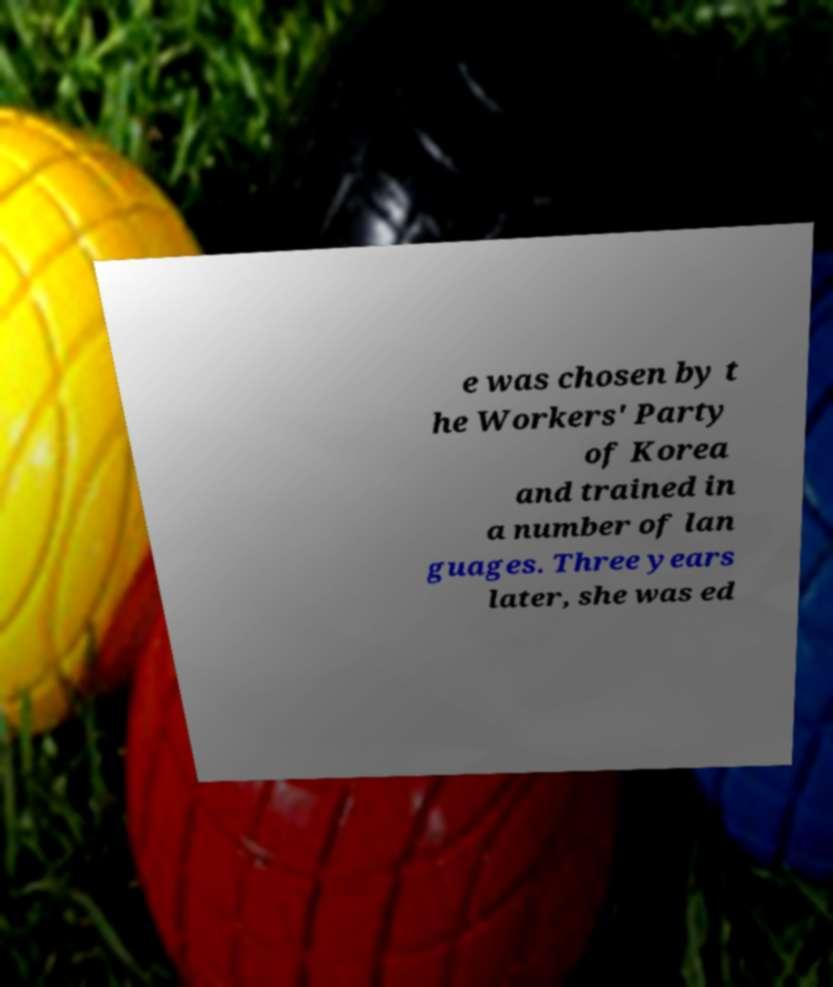Please read and relay the text visible in this image. What does it say? e was chosen by t he Workers' Party of Korea and trained in a number of lan guages. Three years later, she was ed 